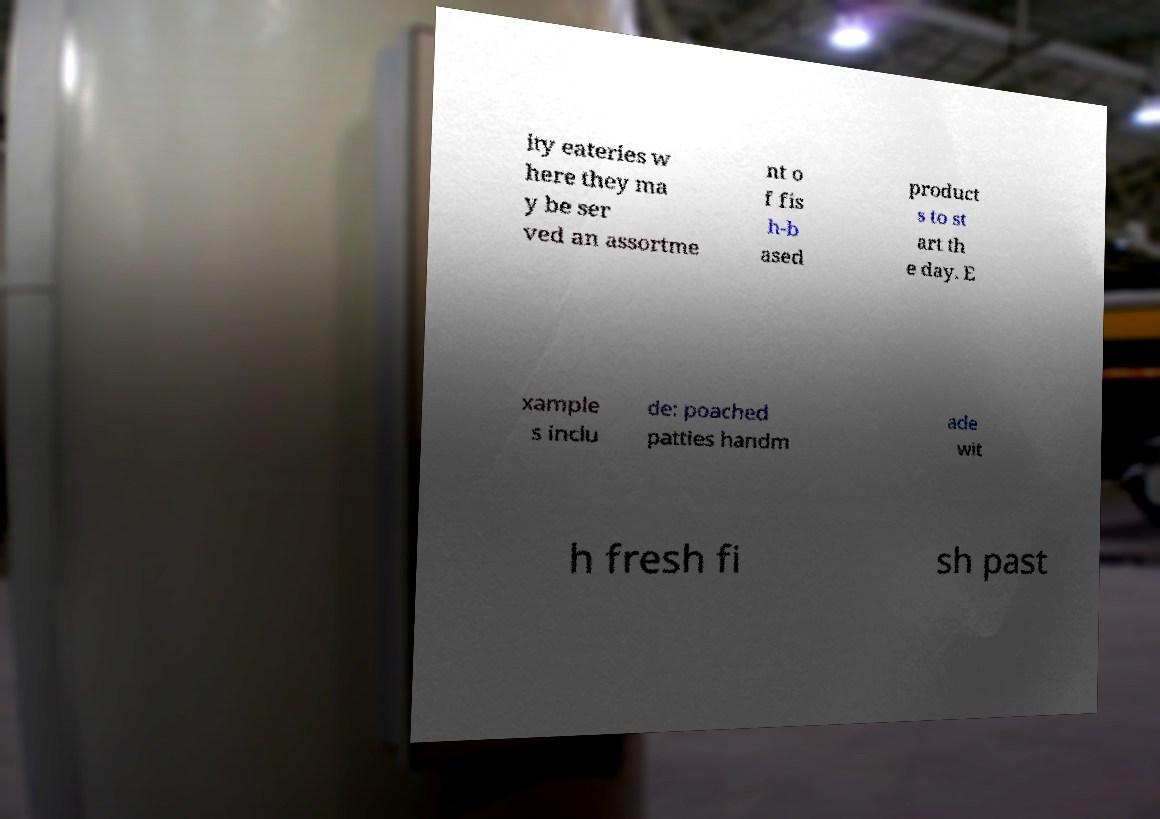Can you accurately transcribe the text from the provided image for me? ity eateries w here they ma y be ser ved an assortme nt o f fis h-b ased product s to st art th e day. E xample s inclu de: poached patties handm ade wit h fresh fi sh past 